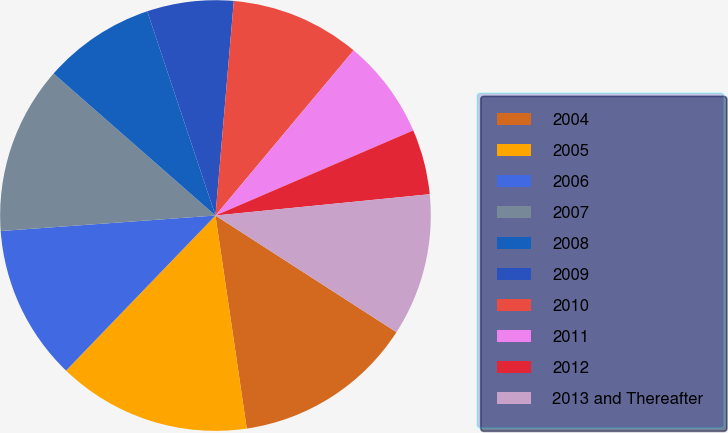<chart> <loc_0><loc_0><loc_500><loc_500><pie_chart><fcel>2004<fcel>2005<fcel>2006<fcel>2007<fcel>2008<fcel>2009<fcel>2010<fcel>2011<fcel>2012<fcel>2013 and Thereafter<nl><fcel>13.57%<fcel>14.53%<fcel>11.65%<fcel>12.61%<fcel>8.41%<fcel>6.49%<fcel>9.73%<fcel>7.45%<fcel>4.89%<fcel>10.69%<nl></chart> 